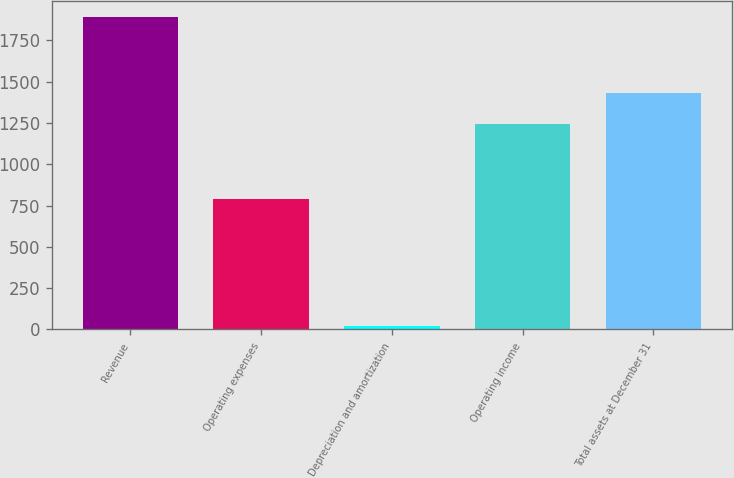<chart> <loc_0><loc_0><loc_500><loc_500><bar_chart><fcel>Revenue<fcel>Operating expenses<fcel>Depreciation and amortization<fcel>Operating income<fcel>Total assets at December 31<nl><fcel>1894.3<fcel>789.1<fcel>22.9<fcel>1242.9<fcel>1430.04<nl></chart> 